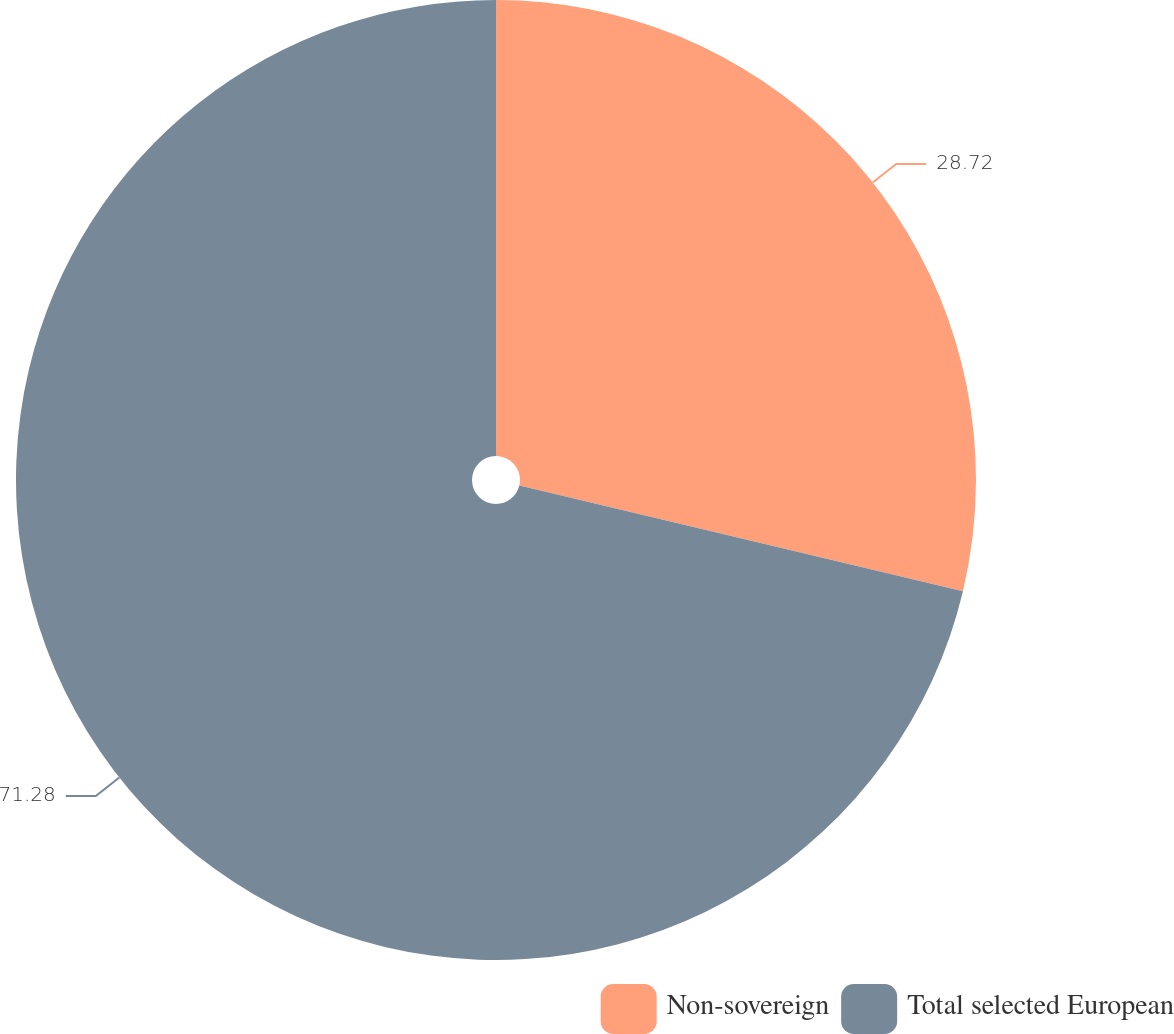Convert chart to OTSL. <chart><loc_0><loc_0><loc_500><loc_500><pie_chart><fcel>Non-sovereign<fcel>Total selected European<nl><fcel>28.72%<fcel>71.28%<nl></chart> 